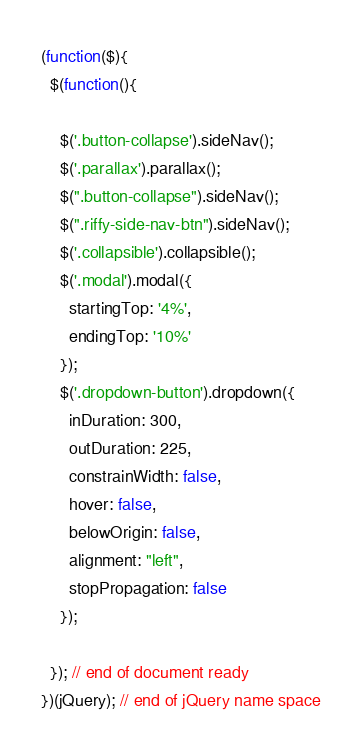Convert code to text. <code><loc_0><loc_0><loc_500><loc_500><_JavaScript_>(function($){
  $(function(){

    $('.button-collapse').sideNav();
    $('.parallax').parallax();
    $(".button-collapse").sideNav();
    $(".riffy-side-nav-btn").sideNav();
    $('.collapsible').collapsible();
    $('.modal').modal({
      startingTop: '4%',
      endingTop: '10%'
    });
    $('.dropdown-button').dropdown({
      inDuration: 300,
      outDuration: 225,
      constrainWidth: false,
      hover: false,
      belowOrigin: false,
      alignment: "left",
      stopPropagation: false
    });

  }); // end of document ready
})(jQuery); // end of jQuery name space
</code> 